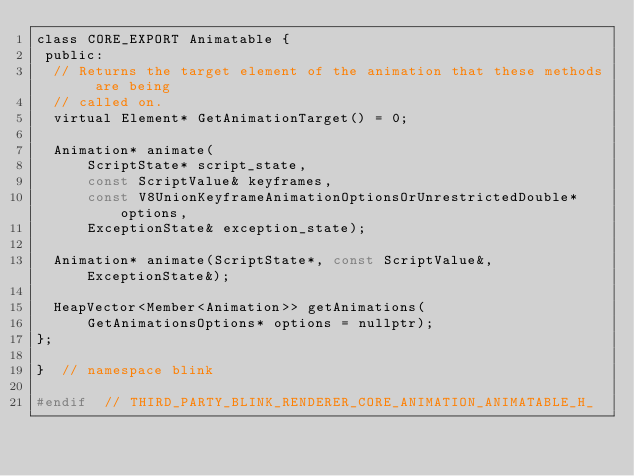<code> <loc_0><loc_0><loc_500><loc_500><_C_>class CORE_EXPORT Animatable {
 public:
  // Returns the target element of the animation that these methods are being
  // called on.
  virtual Element* GetAnimationTarget() = 0;

  Animation* animate(
      ScriptState* script_state,
      const ScriptValue& keyframes,
      const V8UnionKeyframeAnimationOptionsOrUnrestrictedDouble* options,
      ExceptionState& exception_state);

  Animation* animate(ScriptState*, const ScriptValue&, ExceptionState&);

  HeapVector<Member<Animation>> getAnimations(
      GetAnimationsOptions* options = nullptr);
};

}  // namespace blink

#endif  // THIRD_PARTY_BLINK_RENDERER_CORE_ANIMATION_ANIMATABLE_H_
</code> 